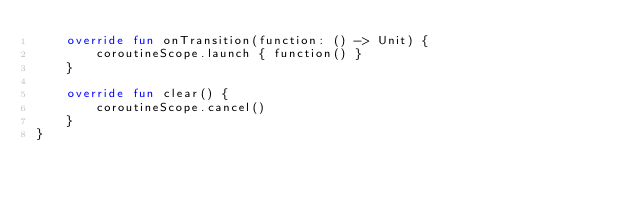<code> <loc_0><loc_0><loc_500><loc_500><_Kotlin_>    override fun onTransition(function: () -> Unit) {
        coroutineScope.launch { function() }
    }

    override fun clear() {
        coroutineScope.cancel()
    }
}
</code> 